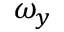<formula> <loc_0><loc_0><loc_500><loc_500>\omega _ { y }</formula> 